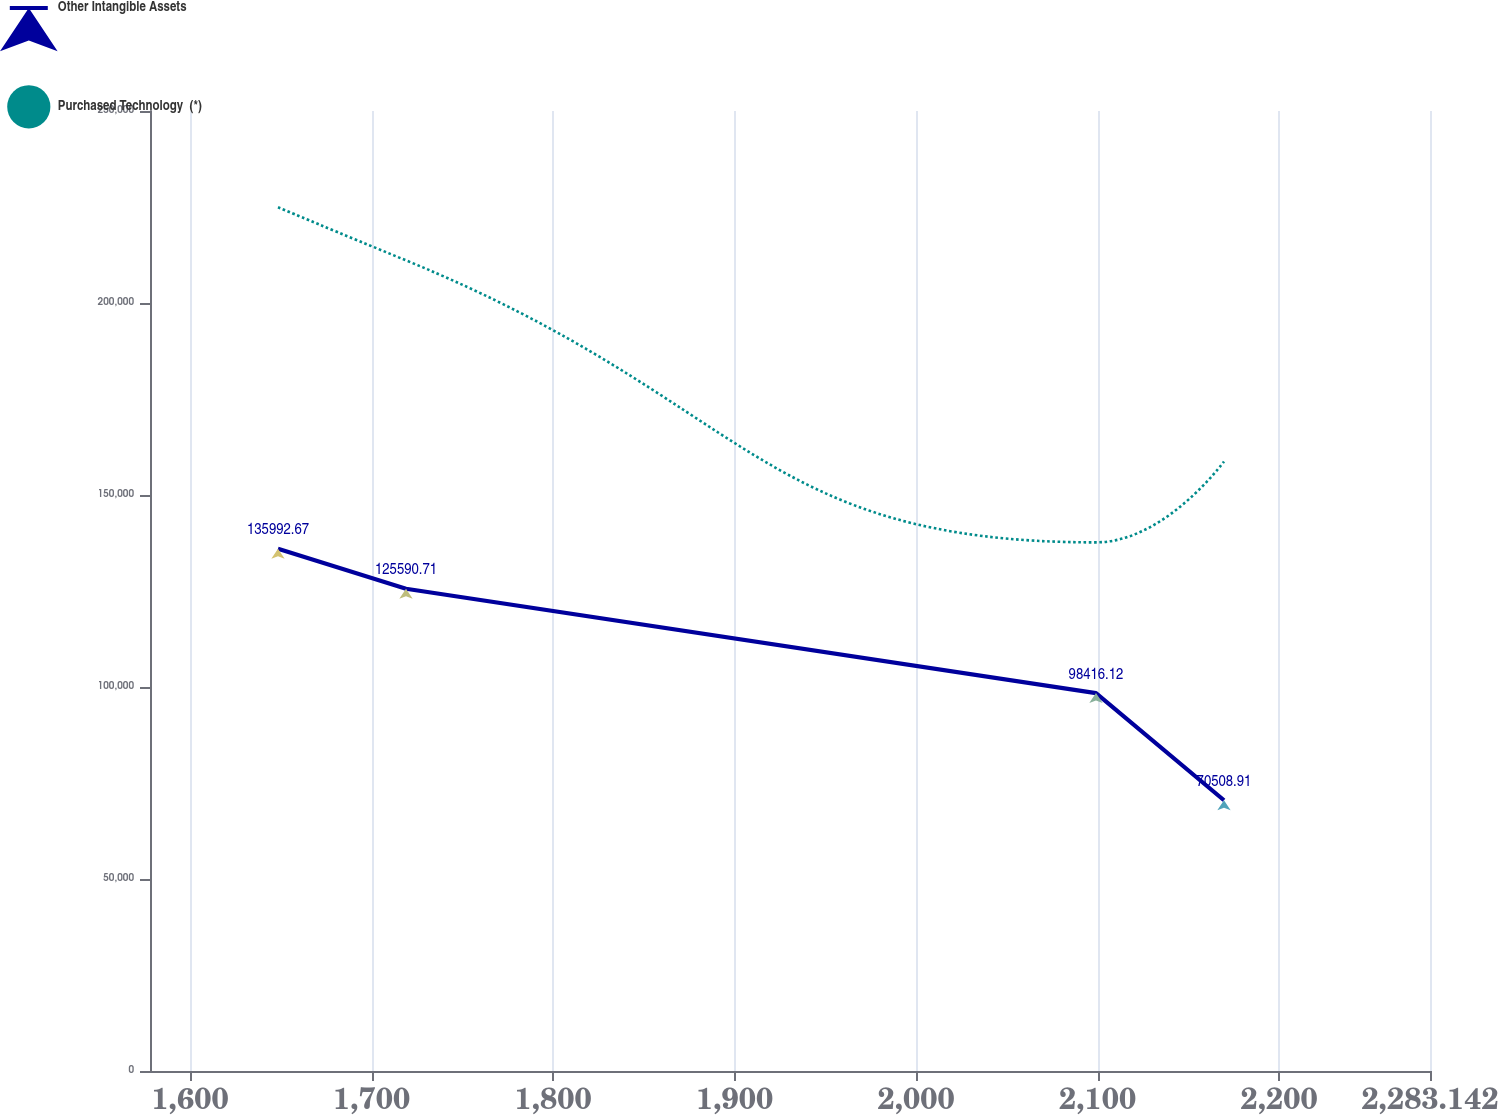<chart> <loc_0><loc_0><loc_500><loc_500><line_chart><ecel><fcel>Other Intangible Assets<fcel>Purchased Technology  (*)<nl><fcel>1648.48<fcel>135993<fcel>224923<nl><fcel>1719<fcel>125591<fcel>211104<nl><fcel>2099.12<fcel>98416.1<fcel>137664<nl><fcel>2169.64<fcel>70508.9<fcel>158727<nl><fcel>2353.66<fcel>81397.4<fcel>150001<nl></chart> 